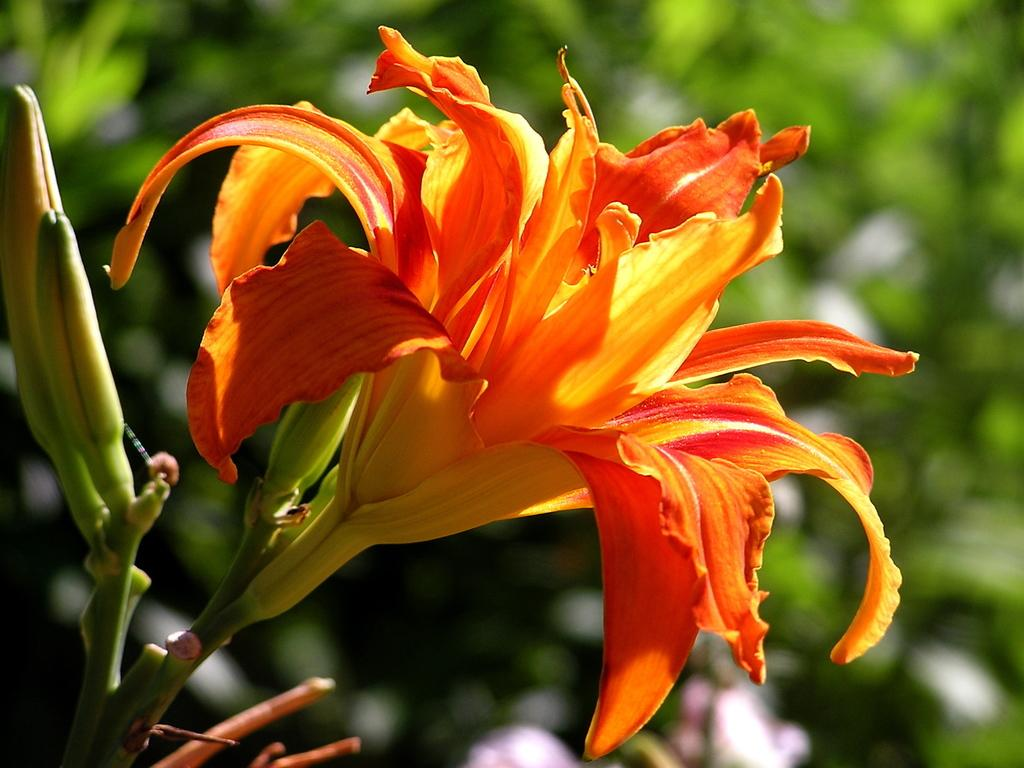What type of flower is in the image? There is a yellow and orange color flower in the image. What colors are present in the flower? The flower has yellow and orange colors. What can be seen in the background of the image? The background of the image is green. What type of care does the baby need in the image? There is no baby present in the image, so it is not possible to determine what type of care the baby might need. 